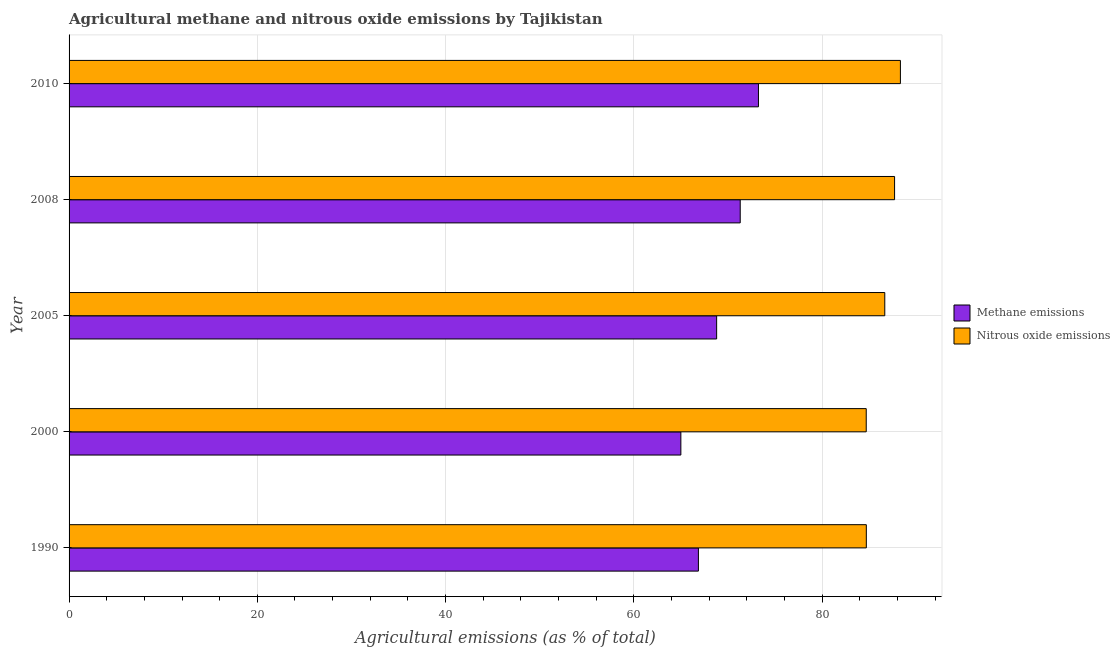How many different coloured bars are there?
Your answer should be compact. 2. How many groups of bars are there?
Your answer should be compact. 5. Are the number of bars per tick equal to the number of legend labels?
Offer a very short reply. Yes. Are the number of bars on each tick of the Y-axis equal?
Provide a succinct answer. Yes. How many bars are there on the 4th tick from the top?
Give a very brief answer. 2. What is the label of the 1st group of bars from the top?
Provide a succinct answer. 2010. In how many cases, is the number of bars for a given year not equal to the number of legend labels?
Offer a very short reply. 0. What is the amount of methane emissions in 2000?
Your answer should be compact. 65. Across all years, what is the maximum amount of nitrous oxide emissions?
Ensure brevity in your answer.  88.32. Across all years, what is the minimum amount of nitrous oxide emissions?
Provide a succinct answer. 84.69. In which year was the amount of nitrous oxide emissions minimum?
Ensure brevity in your answer.  2000. What is the total amount of nitrous oxide emissions in the graph?
Your answer should be compact. 432.07. What is the difference between the amount of methane emissions in 2000 and that in 2010?
Offer a very short reply. -8.24. What is the difference between the amount of methane emissions in 2010 and the amount of nitrous oxide emissions in 1990?
Provide a succinct answer. -11.46. What is the average amount of methane emissions per year?
Offer a terse response. 69.04. In the year 2005, what is the difference between the amount of nitrous oxide emissions and amount of methane emissions?
Your response must be concise. 17.86. What is the ratio of the amount of methane emissions in 2005 to that in 2008?
Provide a succinct answer. 0.96. Is the amount of methane emissions in 2000 less than that in 2008?
Ensure brevity in your answer.  Yes. What is the difference between the highest and the second highest amount of nitrous oxide emissions?
Provide a short and direct response. 0.62. What is the difference between the highest and the lowest amount of nitrous oxide emissions?
Your answer should be compact. 3.63. What does the 2nd bar from the top in 2008 represents?
Your response must be concise. Methane emissions. What does the 1st bar from the bottom in 2000 represents?
Give a very brief answer. Methane emissions. Are all the bars in the graph horizontal?
Your answer should be very brief. Yes. How many years are there in the graph?
Your answer should be compact. 5. Are the values on the major ticks of X-axis written in scientific E-notation?
Your answer should be very brief. No. Does the graph contain any zero values?
Offer a very short reply. No. Does the graph contain grids?
Keep it short and to the point. Yes. Where does the legend appear in the graph?
Your response must be concise. Center right. What is the title of the graph?
Give a very brief answer. Agricultural methane and nitrous oxide emissions by Tajikistan. Does "Urban agglomerations" appear as one of the legend labels in the graph?
Offer a terse response. No. What is the label or title of the X-axis?
Offer a very short reply. Agricultural emissions (as % of total). What is the Agricultural emissions (as % of total) in Methane emissions in 1990?
Provide a succinct answer. 66.86. What is the Agricultural emissions (as % of total) in Nitrous oxide emissions in 1990?
Provide a short and direct response. 84.7. What is the Agricultural emissions (as % of total) of Methane emissions in 2000?
Give a very brief answer. 65. What is the Agricultural emissions (as % of total) in Nitrous oxide emissions in 2000?
Provide a short and direct response. 84.69. What is the Agricultural emissions (as % of total) in Methane emissions in 2005?
Your answer should be compact. 68.8. What is the Agricultural emissions (as % of total) of Nitrous oxide emissions in 2005?
Give a very brief answer. 86.66. What is the Agricultural emissions (as % of total) in Methane emissions in 2008?
Your response must be concise. 71.3. What is the Agricultural emissions (as % of total) of Nitrous oxide emissions in 2008?
Ensure brevity in your answer.  87.7. What is the Agricultural emissions (as % of total) in Methane emissions in 2010?
Ensure brevity in your answer.  73.24. What is the Agricultural emissions (as % of total) of Nitrous oxide emissions in 2010?
Provide a short and direct response. 88.32. Across all years, what is the maximum Agricultural emissions (as % of total) in Methane emissions?
Make the answer very short. 73.24. Across all years, what is the maximum Agricultural emissions (as % of total) of Nitrous oxide emissions?
Your response must be concise. 88.32. Across all years, what is the minimum Agricultural emissions (as % of total) of Methane emissions?
Offer a very short reply. 65. Across all years, what is the minimum Agricultural emissions (as % of total) of Nitrous oxide emissions?
Ensure brevity in your answer.  84.69. What is the total Agricultural emissions (as % of total) in Methane emissions in the graph?
Give a very brief answer. 345.19. What is the total Agricultural emissions (as % of total) in Nitrous oxide emissions in the graph?
Give a very brief answer. 432.07. What is the difference between the Agricultural emissions (as % of total) of Methane emissions in 1990 and that in 2000?
Provide a succinct answer. 1.86. What is the difference between the Agricultural emissions (as % of total) of Nitrous oxide emissions in 1990 and that in 2000?
Your answer should be compact. 0.01. What is the difference between the Agricultural emissions (as % of total) in Methane emissions in 1990 and that in 2005?
Ensure brevity in your answer.  -1.94. What is the difference between the Agricultural emissions (as % of total) in Nitrous oxide emissions in 1990 and that in 2005?
Offer a terse response. -1.96. What is the difference between the Agricultural emissions (as % of total) in Methane emissions in 1990 and that in 2008?
Provide a succinct answer. -4.44. What is the difference between the Agricultural emissions (as % of total) of Nitrous oxide emissions in 1990 and that in 2008?
Your answer should be compact. -3. What is the difference between the Agricultural emissions (as % of total) in Methane emissions in 1990 and that in 2010?
Your answer should be compact. -6.38. What is the difference between the Agricultural emissions (as % of total) of Nitrous oxide emissions in 1990 and that in 2010?
Ensure brevity in your answer.  -3.62. What is the difference between the Agricultural emissions (as % of total) in Methane emissions in 2000 and that in 2005?
Ensure brevity in your answer.  -3.8. What is the difference between the Agricultural emissions (as % of total) in Nitrous oxide emissions in 2000 and that in 2005?
Provide a succinct answer. -1.97. What is the difference between the Agricultural emissions (as % of total) of Methane emissions in 2000 and that in 2008?
Keep it short and to the point. -6.31. What is the difference between the Agricultural emissions (as % of total) in Nitrous oxide emissions in 2000 and that in 2008?
Your answer should be compact. -3.01. What is the difference between the Agricultural emissions (as % of total) in Methane emissions in 2000 and that in 2010?
Offer a very short reply. -8.24. What is the difference between the Agricultural emissions (as % of total) in Nitrous oxide emissions in 2000 and that in 2010?
Give a very brief answer. -3.63. What is the difference between the Agricultural emissions (as % of total) in Methane emissions in 2005 and that in 2008?
Give a very brief answer. -2.51. What is the difference between the Agricultural emissions (as % of total) of Nitrous oxide emissions in 2005 and that in 2008?
Give a very brief answer. -1.04. What is the difference between the Agricultural emissions (as % of total) of Methane emissions in 2005 and that in 2010?
Make the answer very short. -4.44. What is the difference between the Agricultural emissions (as % of total) in Nitrous oxide emissions in 2005 and that in 2010?
Your answer should be very brief. -1.66. What is the difference between the Agricultural emissions (as % of total) in Methane emissions in 2008 and that in 2010?
Give a very brief answer. -1.94. What is the difference between the Agricultural emissions (as % of total) in Nitrous oxide emissions in 2008 and that in 2010?
Ensure brevity in your answer.  -0.62. What is the difference between the Agricultural emissions (as % of total) of Methane emissions in 1990 and the Agricultural emissions (as % of total) of Nitrous oxide emissions in 2000?
Make the answer very short. -17.83. What is the difference between the Agricultural emissions (as % of total) in Methane emissions in 1990 and the Agricultural emissions (as % of total) in Nitrous oxide emissions in 2005?
Keep it short and to the point. -19.8. What is the difference between the Agricultural emissions (as % of total) of Methane emissions in 1990 and the Agricultural emissions (as % of total) of Nitrous oxide emissions in 2008?
Provide a succinct answer. -20.84. What is the difference between the Agricultural emissions (as % of total) in Methane emissions in 1990 and the Agricultural emissions (as % of total) in Nitrous oxide emissions in 2010?
Your response must be concise. -21.46. What is the difference between the Agricultural emissions (as % of total) in Methane emissions in 2000 and the Agricultural emissions (as % of total) in Nitrous oxide emissions in 2005?
Provide a short and direct response. -21.66. What is the difference between the Agricultural emissions (as % of total) of Methane emissions in 2000 and the Agricultural emissions (as % of total) of Nitrous oxide emissions in 2008?
Keep it short and to the point. -22.7. What is the difference between the Agricultural emissions (as % of total) of Methane emissions in 2000 and the Agricultural emissions (as % of total) of Nitrous oxide emissions in 2010?
Your response must be concise. -23.33. What is the difference between the Agricultural emissions (as % of total) in Methane emissions in 2005 and the Agricultural emissions (as % of total) in Nitrous oxide emissions in 2008?
Your answer should be compact. -18.9. What is the difference between the Agricultural emissions (as % of total) of Methane emissions in 2005 and the Agricultural emissions (as % of total) of Nitrous oxide emissions in 2010?
Ensure brevity in your answer.  -19.52. What is the difference between the Agricultural emissions (as % of total) in Methane emissions in 2008 and the Agricultural emissions (as % of total) in Nitrous oxide emissions in 2010?
Provide a short and direct response. -17.02. What is the average Agricultural emissions (as % of total) in Methane emissions per year?
Your answer should be compact. 69.04. What is the average Agricultural emissions (as % of total) in Nitrous oxide emissions per year?
Give a very brief answer. 86.41. In the year 1990, what is the difference between the Agricultural emissions (as % of total) of Methane emissions and Agricultural emissions (as % of total) of Nitrous oxide emissions?
Keep it short and to the point. -17.84. In the year 2000, what is the difference between the Agricultural emissions (as % of total) in Methane emissions and Agricultural emissions (as % of total) in Nitrous oxide emissions?
Offer a terse response. -19.69. In the year 2005, what is the difference between the Agricultural emissions (as % of total) in Methane emissions and Agricultural emissions (as % of total) in Nitrous oxide emissions?
Offer a very short reply. -17.86. In the year 2008, what is the difference between the Agricultural emissions (as % of total) of Methane emissions and Agricultural emissions (as % of total) of Nitrous oxide emissions?
Give a very brief answer. -16.4. In the year 2010, what is the difference between the Agricultural emissions (as % of total) of Methane emissions and Agricultural emissions (as % of total) of Nitrous oxide emissions?
Provide a short and direct response. -15.08. What is the ratio of the Agricultural emissions (as % of total) of Methane emissions in 1990 to that in 2000?
Keep it short and to the point. 1.03. What is the ratio of the Agricultural emissions (as % of total) in Nitrous oxide emissions in 1990 to that in 2000?
Your answer should be very brief. 1. What is the ratio of the Agricultural emissions (as % of total) of Methane emissions in 1990 to that in 2005?
Make the answer very short. 0.97. What is the ratio of the Agricultural emissions (as % of total) in Nitrous oxide emissions in 1990 to that in 2005?
Offer a very short reply. 0.98. What is the ratio of the Agricultural emissions (as % of total) of Methane emissions in 1990 to that in 2008?
Your response must be concise. 0.94. What is the ratio of the Agricultural emissions (as % of total) of Nitrous oxide emissions in 1990 to that in 2008?
Keep it short and to the point. 0.97. What is the ratio of the Agricultural emissions (as % of total) of Methane emissions in 1990 to that in 2010?
Offer a terse response. 0.91. What is the ratio of the Agricultural emissions (as % of total) of Nitrous oxide emissions in 1990 to that in 2010?
Make the answer very short. 0.96. What is the ratio of the Agricultural emissions (as % of total) in Methane emissions in 2000 to that in 2005?
Ensure brevity in your answer.  0.94. What is the ratio of the Agricultural emissions (as % of total) in Nitrous oxide emissions in 2000 to that in 2005?
Keep it short and to the point. 0.98. What is the ratio of the Agricultural emissions (as % of total) in Methane emissions in 2000 to that in 2008?
Give a very brief answer. 0.91. What is the ratio of the Agricultural emissions (as % of total) of Nitrous oxide emissions in 2000 to that in 2008?
Keep it short and to the point. 0.97. What is the ratio of the Agricultural emissions (as % of total) in Methane emissions in 2000 to that in 2010?
Offer a terse response. 0.89. What is the ratio of the Agricultural emissions (as % of total) of Nitrous oxide emissions in 2000 to that in 2010?
Keep it short and to the point. 0.96. What is the ratio of the Agricultural emissions (as % of total) of Methane emissions in 2005 to that in 2008?
Ensure brevity in your answer.  0.96. What is the ratio of the Agricultural emissions (as % of total) of Methane emissions in 2005 to that in 2010?
Your answer should be very brief. 0.94. What is the ratio of the Agricultural emissions (as % of total) in Nitrous oxide emissions in 2005 to that in 2010?
Provide a short and direct response. 0.98. What is the ratio of the Agricultural emissions (as % of total) in Methane emissions in 2008 to that in 2010?
Your answer should be very brief. 0.97. What is the ratio of the Agricultural emissions (as % of total) of Nitrous oxide emissions in 2008 to that in 2010?
Give a very brief answer. 0.99. What is the difference between the highest and the second highest Agricultural emissions (as % of total) in Methane emissions?
Ensure brevity in your answer.  1.94. What is the difference between the highest and the second highest Agricultural emissions (as % of total) of Nitrous oxide emissions?
Provide a short and direct response. 0.62. What is the difference between the highest and the lowest Agricultural emissions (as % of total) in Methane emissions?
Offer a very short reply. 8.24. What is the difference between the highest and the lowest Agricultural emissions (as % of total) of Nitrous oxide emissions?
Offer a very short reply. 3.63. 